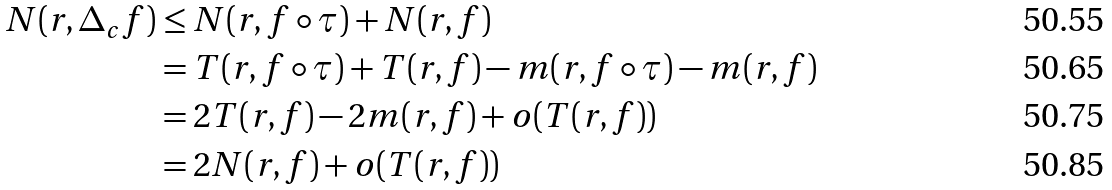<formula> <loc_0><loc_0><loc_500><loc_500>N ( r , \Delta _ { c } f ) & \leq N ( r , f \circ \tau ) + N ( r , f ) \\ & = T ( r , f \circ \tau ) + T ( r , f ) - m ( r , f \circ \tau ) - m ( r , f ) \\ & = 2 T ( r , f ) - 2 m ( r , f ) + o ( T ( r , f ) ) \\ & = 2 N ( r , f ) + o ( T ( r , f ) )</formula> 